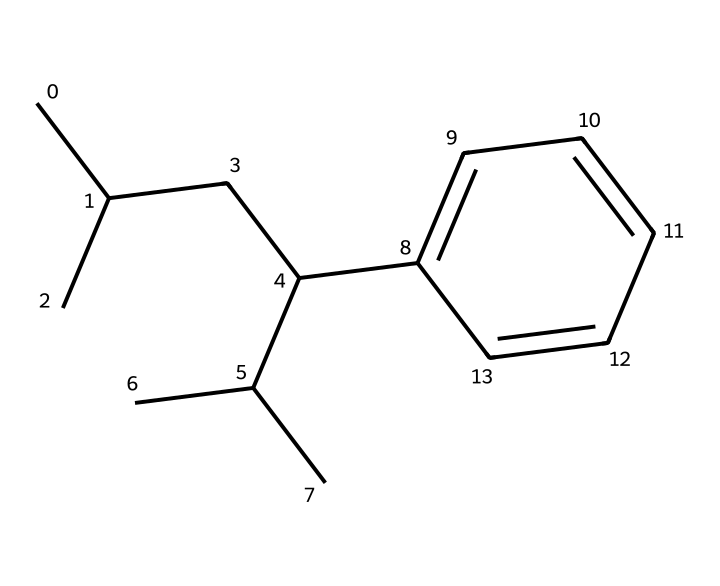What is the total number of carbon atoms in this molecule? To determine the total number of carbon atoms, count each carbon (C) symbol in the SMILES representation. There are 15 carbon atoms present.
Answer: 15 How many hydrogen atoms are attached to this structure? Each carbon typically has four bonds. By analyzing the structure represented by the SMILES, we can see that there are 24 hydrogen atoms bonded to the carbon skeleton based on how many are necessary to satisfy the tetravalency of the carbon atoms.
Answer: 24 What type of polymer is this molecule representative of? This molecule is a representation of polystyrene, identified by its aromatic ring structure and long carbon chain. Polystyrene is commonly used in disposable cutlery and food trays due to its lightweight and versatile properties.
Answer: polystyrene What characteristic of polystyrene affects its recyclability? The presence of a highly stable aromatic ring in polystyrene makes it resistant to degradation, which affects its recyclability since it does not break down easily in the environment.
Answer: aromatic ring How does the molecular arrangement of polystyrene contribute to its rigidity? The linear chains of carbon atoms and the strong covalent bonding between them, along with the incorporation of a stiff aromatic ring, contribute to the overall structural rigidity of polystyrene.
Answer: rigidity Which functional groups are absent in this chemical structure? Evaluating the SMILES indicates no presence of functional groups such as hydroxyl (-OH), carboxyl (-COOH), or amine (-NH2), which are common in other organic compounds.
Answer: None What physical property is enhanced by the additives often mixed with polystyrene in disposable products? Additives like plasticizers are added to polystyrene to enhance flexibility, making the final products more suitable for use as disposable cutlery and trays, which require a balance between rigidity and flexibility.
Answer: flexibility 